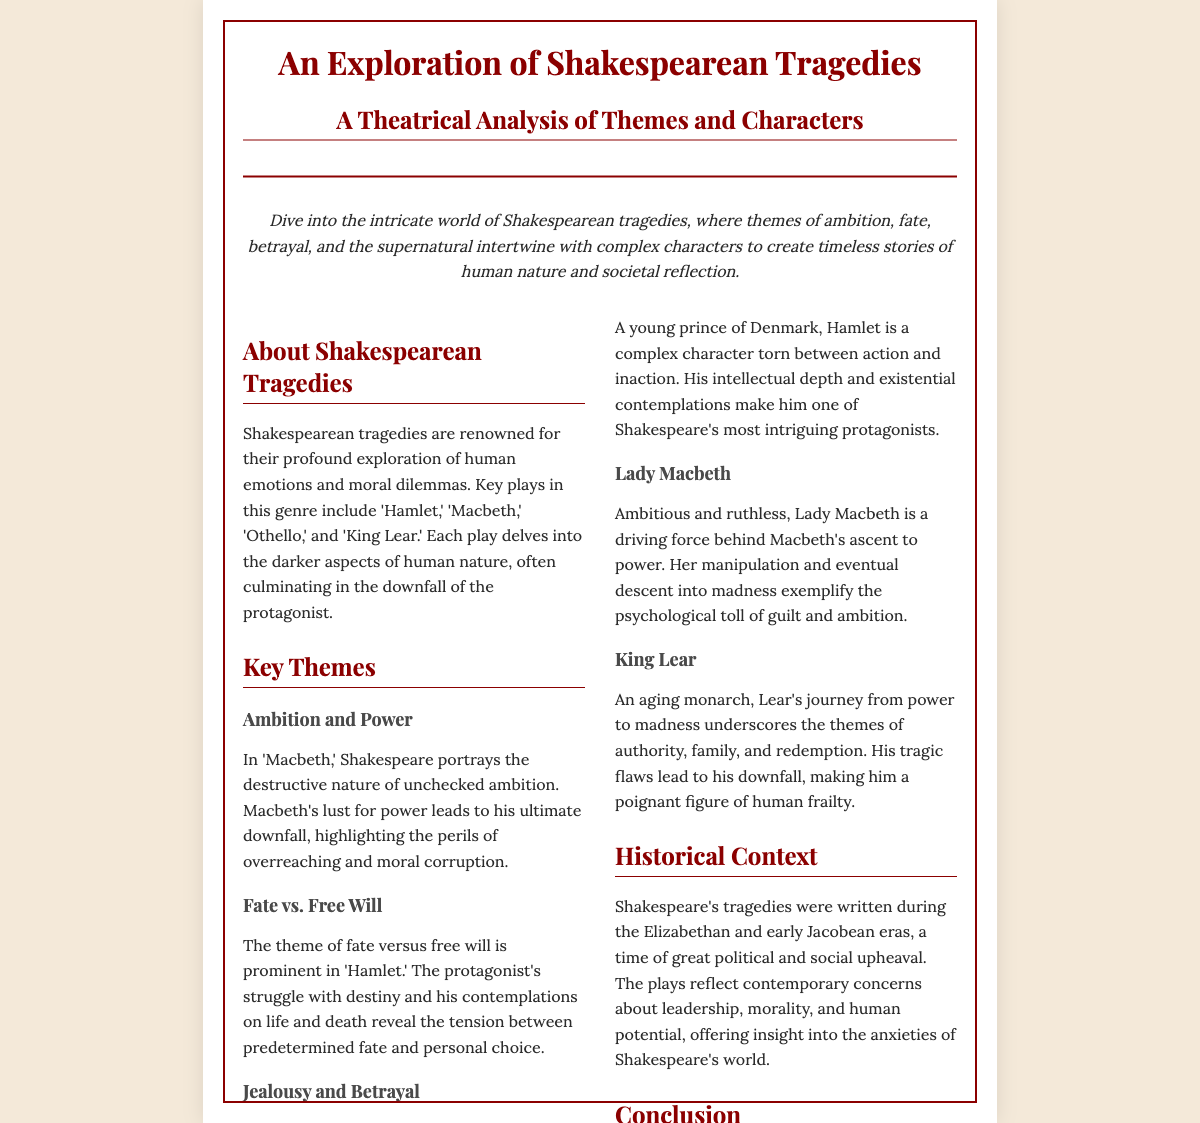What are some key plays in the genre of Shakespearean tragedies? The document lists 'Hamlet,' 'Macbeth,' 'Othello,' and 'King Lear' as key plays in Shakespearean tragedies.
Answer: 'Hamlet,' 'Macbeth,' 'Othello,' and 'King Lear' What theme is explored in 'Macbeth'? The document states that 'Macbeth' portrays the destructive nature of unchecked ambition as a key theme.
Answer: Ambition and Power Who is the protagonist in 'Hamlet'? The character analysis section indicates that Hamlet is the young prince of Denmark, making him the protagonist.
Answer: Hamlet What historical periods did Shakespeare's tragedies reflect? The document mentions the Elizabethan and early Jacobean eras as the historical context for Shakespeare's tragedies.
Answer: Elizabethan and early Jacobean eras Which character undergoes a descent into madness? The document specifies Lady Macbeth's descent into madness due to guilt and ambition.
Answer: Lady Macbeth How does the document describe Shakespearean tragedies? The overview describes Shakespearean tragedies as profoundly exploring human emotions and moral dilemmas.
Answer: Profoundly exploring human emotions and moral dilemmas What is a famous quote from 'Hamlet' included in the document? The footer contains a famous quote from 'Hamlet' that emphasizes a key philosophical query.
Answer: "To be, or not to be, that is the question" What is the conclusion of the document regarding Shakespearean tragedies? The conclusion reflects on the continuing resonance of Shakespearean tragedies with universal themes and complex characters.
Answer: Continue to resonate with audiences due to profound exploration What does the section about character analysis focus on? The character analysis section focuses on key characters such as Hamlet, Lady Macbeth, and King Lear.
Answer: Key characters such as Hamlet, Lady Macbeth, and King Lear 